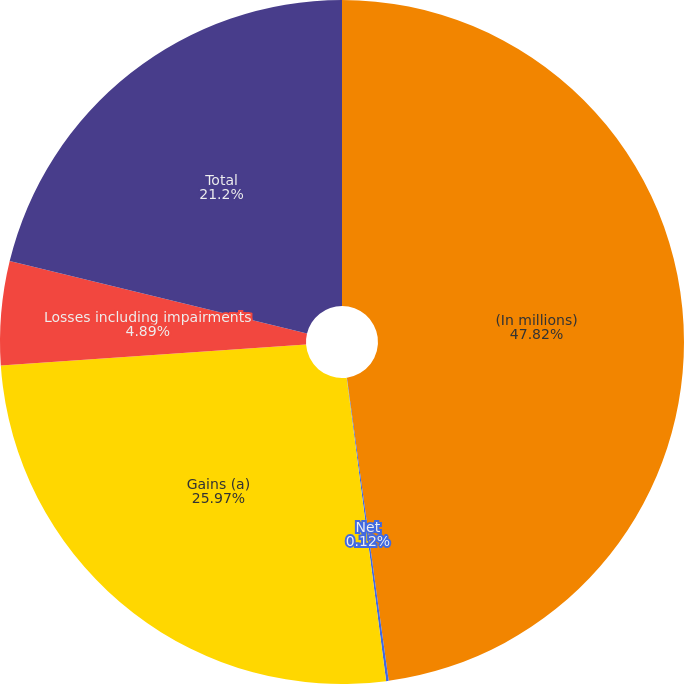<chart> <loc_0><loc_0><loc_500><loc_500><pie_chart><fcel>(In millions)<fcel>Net<fcel>Gains (a)<fcel>Losses including impairments<fcel>Total<nl><fcel>47.82%<fcel>0.12%<fcel>25.97%<fcel>4.89%<fcel>21.2%<nl></chart> 